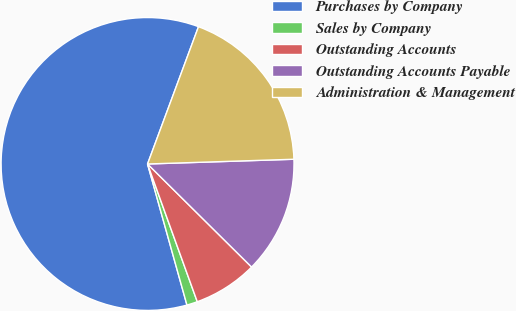Convert chart. <chart><loc_0><loc_0><loc_500><loc_500><pie_chart><fcel>Purchases by Company<fcel>Sales by Company<fcel>Outstanding Accounts<fcel>Outstanding Accounts Payable<fcel>Administration & Management<nl><fcel>59.99%<fcel>1.18%<fcel>7.06%<fcel>12.94%<fcel>18.83%<nl></chart> 